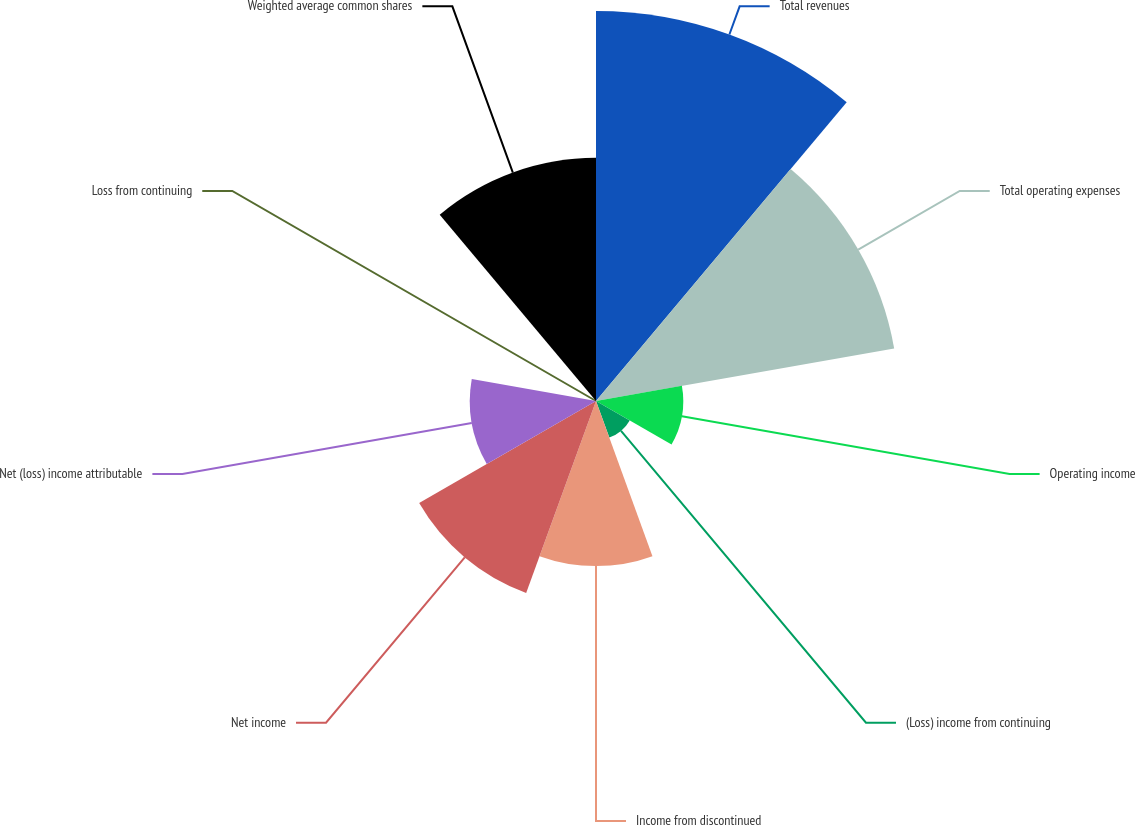<chart> <loc_0><loc_0><loc_500><loc_500><pie_chart><fcel>Total revenues<fcel>Total operating expenses<fcel>Operating income<fcel>(Loss) income from continuing<fcel>Income from discontinued<fcel>Net income<fcel>Net (loss) income attributable<fcel>Loss from continuing<fcel>Weighted average common shares<nl><fcel>25.04%<fcel>19.44%<fcel>5.6%<fcel>2.5%<fcel>10.6%<fcel>13.11%<fcel>8.1%<fcel>0.0%<fcel>15.61%<nl></chart> 